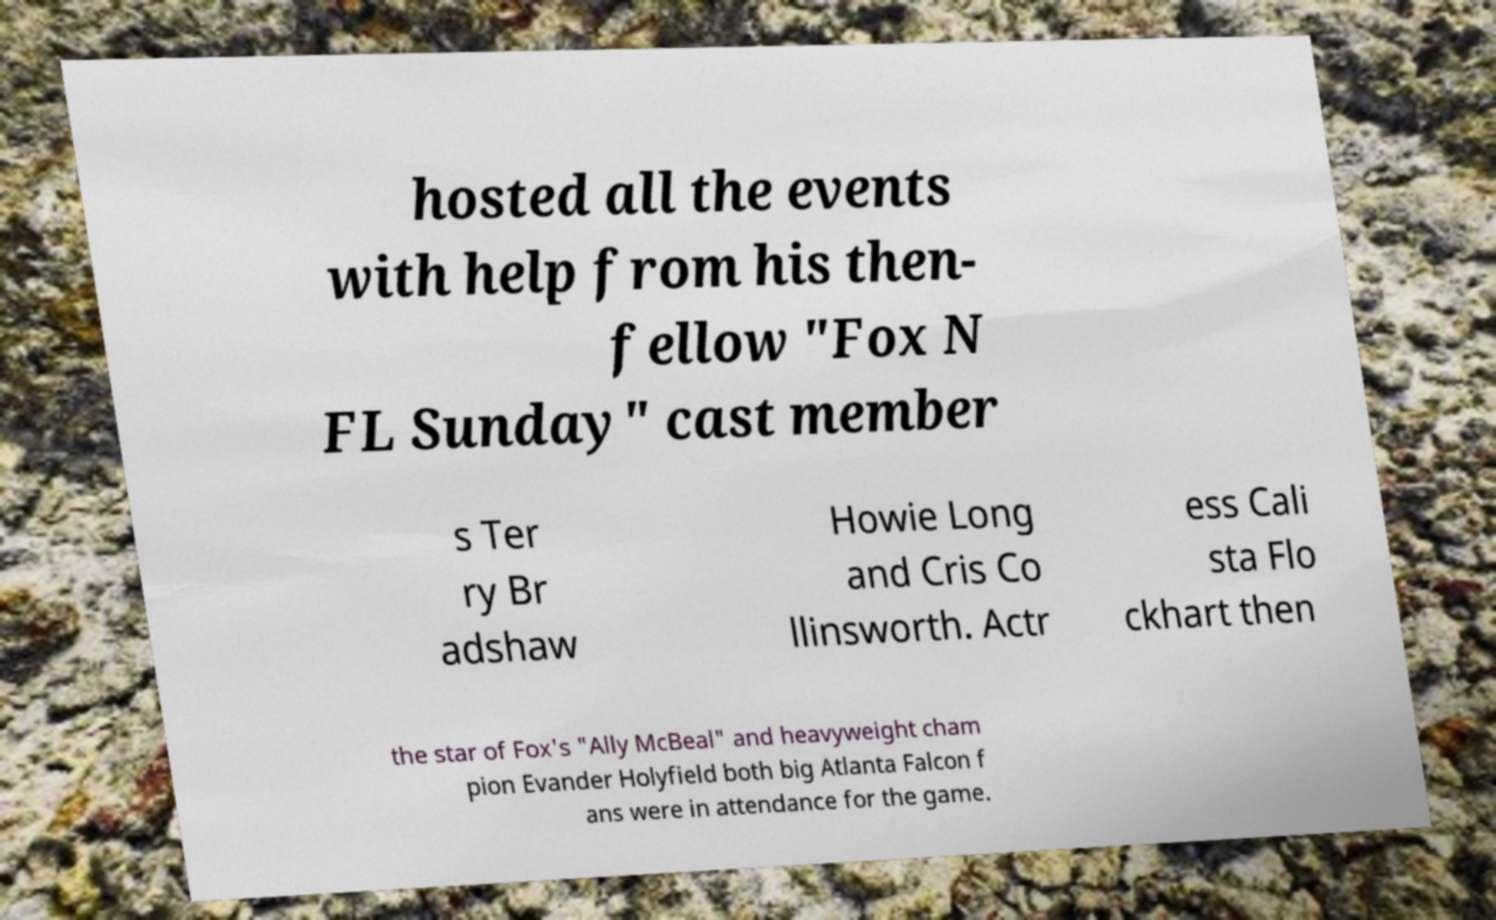I need the written content from this picture converted into text. Can you do that? hosted all the events with help from his then- fellow "Fox N FL Sunday" cast member s Ter ry Br adshaw Howie Long and Cris Co llinsworth. Actr ess Cali sta Flo ckhart then the star of Fox's "Ally McBeal" and heavyweight cham pion Evander Holyfield both big Atlanta Falcon f ans were in attendance for the game. 